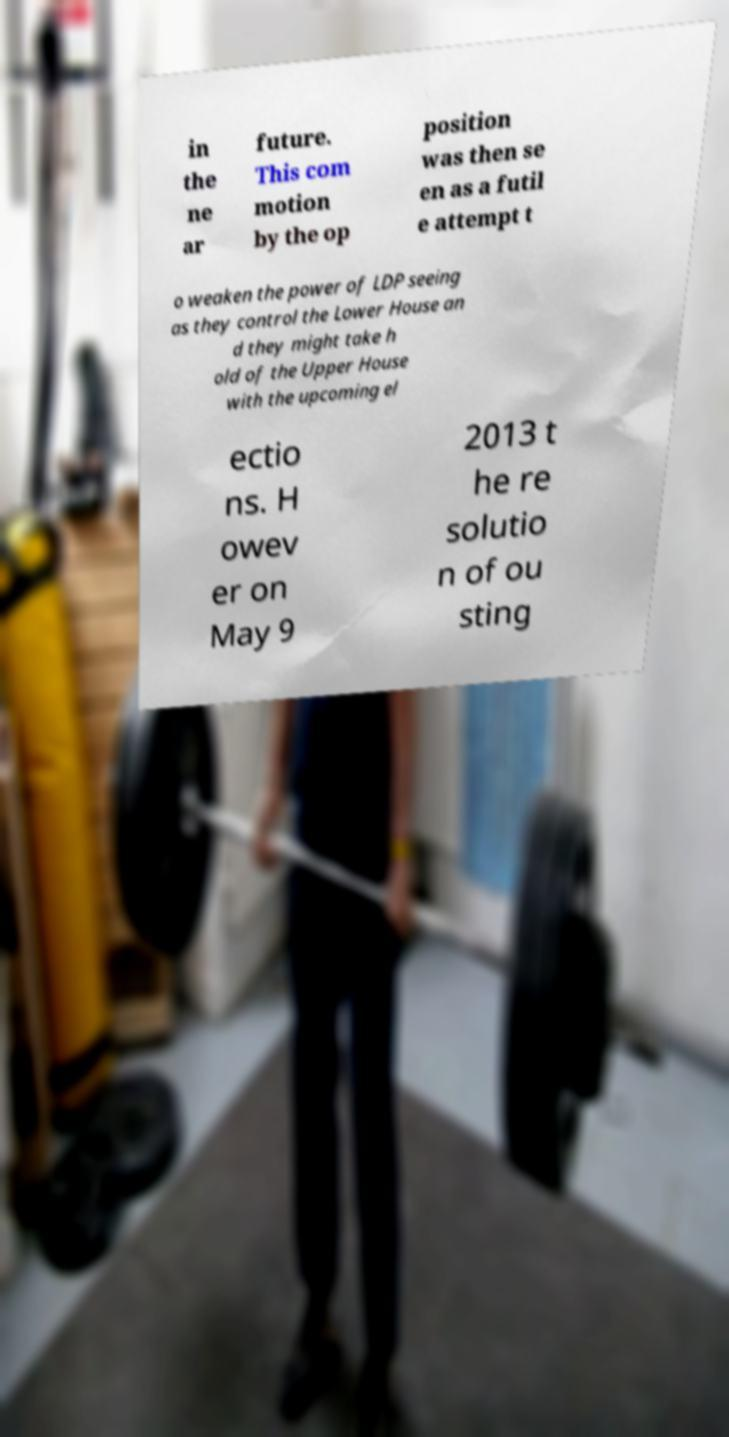Could you extract and type out the text from this image? in the ne ar future. This com motion by the op position was then se en as a futil e attempt t o weaken the power of LDP seeing as they control the Lower House an d they might take h old of the Upper House with the upcoming el ectio ns. H owev er on May 9 2013 t he re solutio n of ou sting 